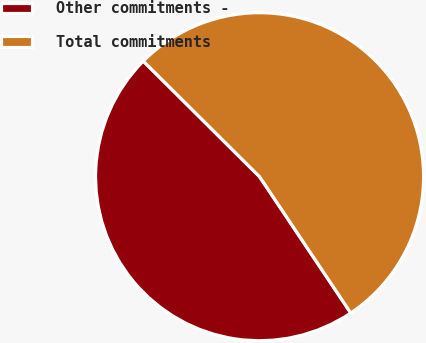<chart> <loc_0><loc_0><loc_500><loc_500><pie_chart><fcel>Other commitments -<fcel>Total commitments<nl><fcel>46.84%<fcel>53.16%<nl></chart> 